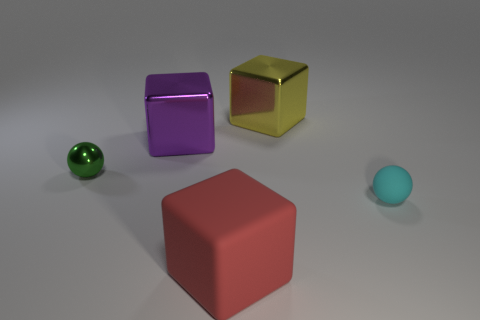Is there anything else that has the same size as the yellow shiny thing?
Your answer should be very brief. Yes. What is the size of the cube that is in front of the small object that is to the left of the cyan matte sphere?
Your answer should be very brief. Large. What material is the red thing that is the same size as the yellow shiny block?
Give a very brief answer. Rubber. Are there any large green cylinders made of the same material as the yellow cube?
Provide a succinct answer. No. What color is the sphere that is to the right of the tiny ball to the left of the big shiny block that is on the right side of the big red rubber thing?
Your response must be concise. Cyan. Is the color of the ball that is on the right side of the small green metal thing the same as the rubber object on the left side of the cyan sphere?
Give a very brief answer. No. Is there any other thing of the same color as the big rubber cube?
Make the answer very short. No. Are there fewer yellow blocks that are to the left of the tiny green shiny thing than small yellow metal balls?
Offer a terse response. No. How many rubber objects are there?
Offer a very short reply. 2. There is a yellow metallic thing; is its shape the same as the green shiny object behind the large matte thing?
Your answer should be very brief. No. 